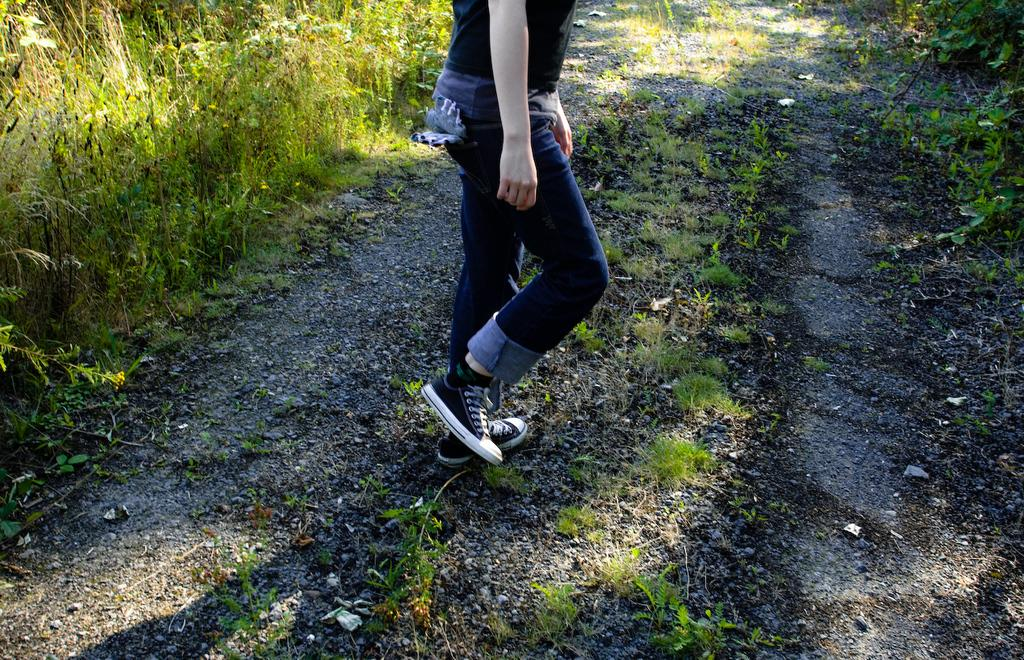Who or what is the main subject of the image? There is a person in the image. What is the person wearing? The person is wearing a black and white dress. What is the person's posture in the image? The person is standing. What type of natural environment is visible in the image? There is grass on the left side of the image. What nation does the person in the image represent? The image does not provide any information about the person's nationality or the nation they represent. 